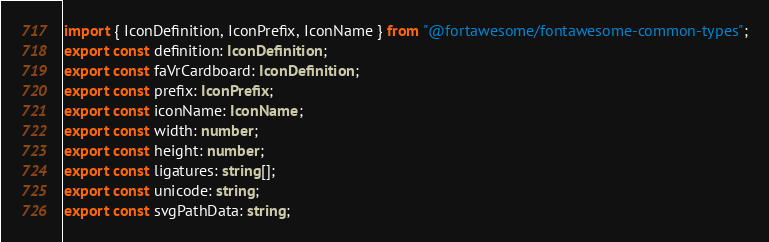Convert code to text. <code><loc_0><loc_0><loc_500><loc_500><_TypeScript_>import { IconDefinition, IconPrefix, IconName } from "@fortawesome/fontawesome-common-types";
export const definition: IconDefinition;
export const faVrCardboard: IconDefinition;
export const prefix: IconPrefix;
export const iconName: IconName;
export const width: number;
export const height: number;
export const ligatures: string[];
export const unicode: string;
export const svgPathData: string;</code> 